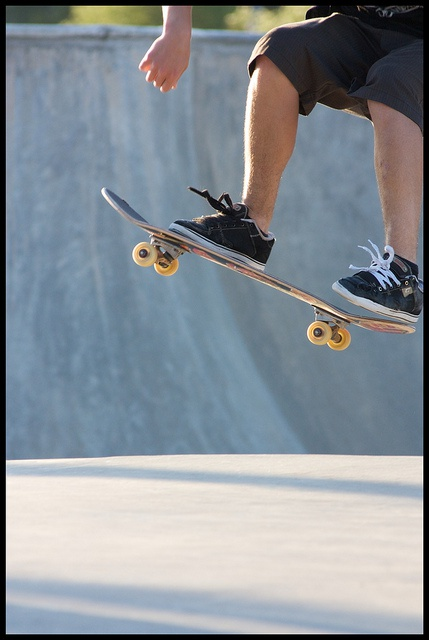Describe the objects in this image and their specific colors. I can see people in black, gray, and darkgray tones and skateboard in black, gray, tan, and darkgray tones in this image. 